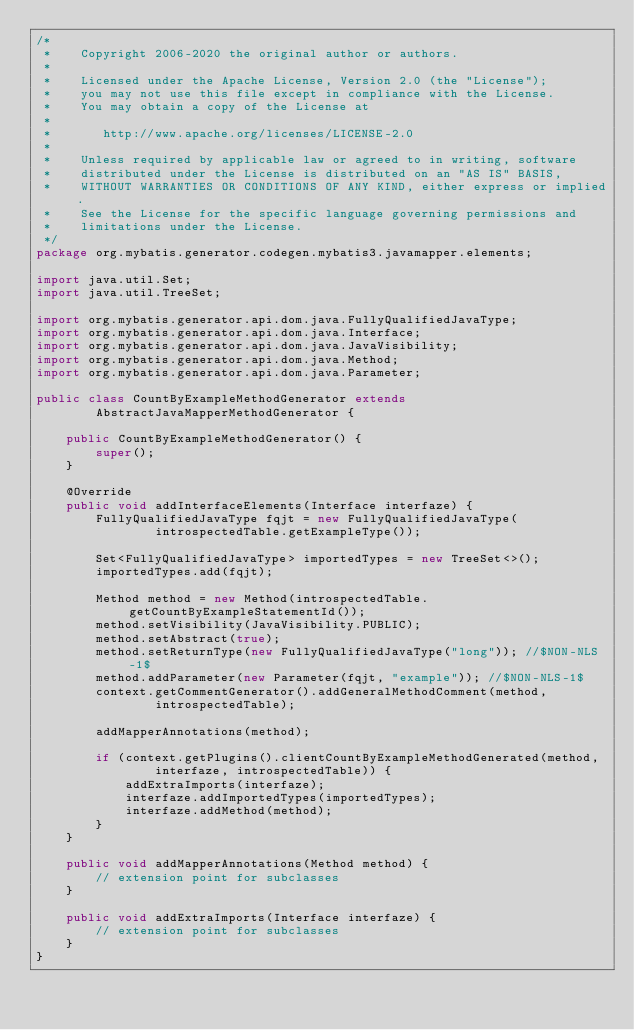<code> <loc_0><loc_0><loc_500><loc_500><_Java_>/*
 *    Copyright 2006-2020 the original author or authors.
 *
 *    Licensed under the Apache License, Version 2.0 (the "License");
 *    you may not use this file except in compliance with the License.
 *    You may obtain a copy of the License at
 *
 *       http://www.apache.org/licenses/LICENSE-2.0
 *
 *    Unless required by applicable law or agreed to in writing, software
 *    distributed under the License is distributed on an "AS IS" BASIS,
 *    WITHOUT WARRANTIES OR CONDITIONS OF ANY KIND, either express or implied.
 *    See the License for the specific language governing permissions and
 *    limitations under the License.
 */
package org.mybatis.generator.codegen.mybatis3.javamapper.elements;

import java.util.Set;
import java.util.TreeSet;

import org.mybatis.generator.api.dom.java.FullyQualifiedJavaType;
import org.mybatis.generator.api.dom.java.Interface;
import org.mybatis.generator.api.dom.java.JavaVisibility;
import org.mybatis.generator.api.dom.java.Method;
import org.mybatis.generator.api.dom.java.Parameter;

public class CountByExampleMethodGenerator extends
        AbstractJavaMapperMethodGenerator {

    public CountByExampleMethodGenerator() {
        super();
    }

    @Override
    public void addInterfaceElements(Interface interfaze) {
        FullyQualifiedJavaType fqjt = new FullyQualifiedJavaType(
                introspectedTable.getExampleType());

        Set<FullyQualifiedJavaType> importedTypes = new TreeSet<>();
        importedTypes.add(fqjt);

        Method method = new Method(introspectedTable.getCountByExampleStatementId());
        method.setVisibility(JavaVisibility.PUBLIC);
        method.setAbstract(true);
        method.setReturnType(new FullyQualifiedJavaType("long")); //$NON-NLS-1$
        method.addParameter(new Parameter(fqjt, "example")); //$NON-NLS-1$
        context.getCommentGenerator().addGeneralMethodComment(method,
                introspectedTable);

        addMapperAnnotations(method);

        if (context.getPlugins().clientCountByExampleMethodGenerated(method,
                interfaze, introspectedTable)) {
            addExtraImports(interfaze);
            interfaze.addImportedTypes(importedTypes);
            interfaze.addMethod(method);
        }
    }

    public void addMapperAnnotations(Method method) {
        // extension point for subclasses
    }

    public void addExtraImports(Interface interfaze) {
        // extension point for subclasses
    }
}
</code> 